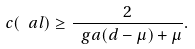<formula> <loc_0><loc_0><loc_500><loc_500>c ( \ a l ) \geq \frac { 2 } { \ g a ( d - \mu ) + \mu } .</formula> 